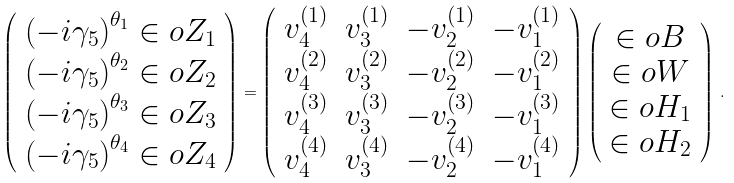<formula> <loc_0><loc_0><loc_500><loc_500>\left ( \begin{array} { c } \left ( - i \gamma _ { 5 } \right ) ^ { \theta _ { 1 } } \in o { Z } _ { 1 } \\ \left ( - i \gamma _ { 5 } \right ) ^ { \theta _ { 2 } } \in o { Z } _ { 2 } \\ \left ( - i \gamma _ { 5 } \right ) ^ { \theta _ { 3 } } \in o { Z } _ { 3 } \\ \left ( - i \gamma _ { 5 } \right ) ^ { \theta _ { 4 } } \in o { Z } _ { 4 } \end{array} \right ) = \left ( \begin{array} { c c c c } v _ { 4 } ^ { ( 1 ) } & v _ { 3 } ^ { ( 1 ) } & - v _ { 2 } ^ { ( 1 ) } & - v _ { 1 } ^ { ( 1 ) } \\ v _ { 4 } ^ { ( 2 ) } & v _ { 3 } ^ { ( 2 ) } & - v _ { 2 } ^ { ( 2 ) } & - v _ { 1 } ^ { ( 2 ) } \\ v _ { 4 } ^ { ( 3 ) } & v _ { 3 } ^ { ( 3 ) } & - v _ { 2 } ^ { ( 3 ) } & - v _ { 1 } ^ { ( 3 ) } \\ v _ { 4 } ^ { ( 4 ) } & v _ { 3 } ^ { ( 4 ) } & - v _ { 2 } ^ { ( 4 ) } & - v _ { 1 } ^ { ( 4 ) } \end{array} \right ) \left ( \begin{array} { c } \in o { B } \\ \in o { W } \\ \in o { H } _ { 1 } \\ \in o { H } _ { 2 } \end{array} \right ) \, .</formula> 